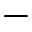Convert formula to latex. <formula><loc_0><loc_0><loc_500><loc_500>-</formula> 